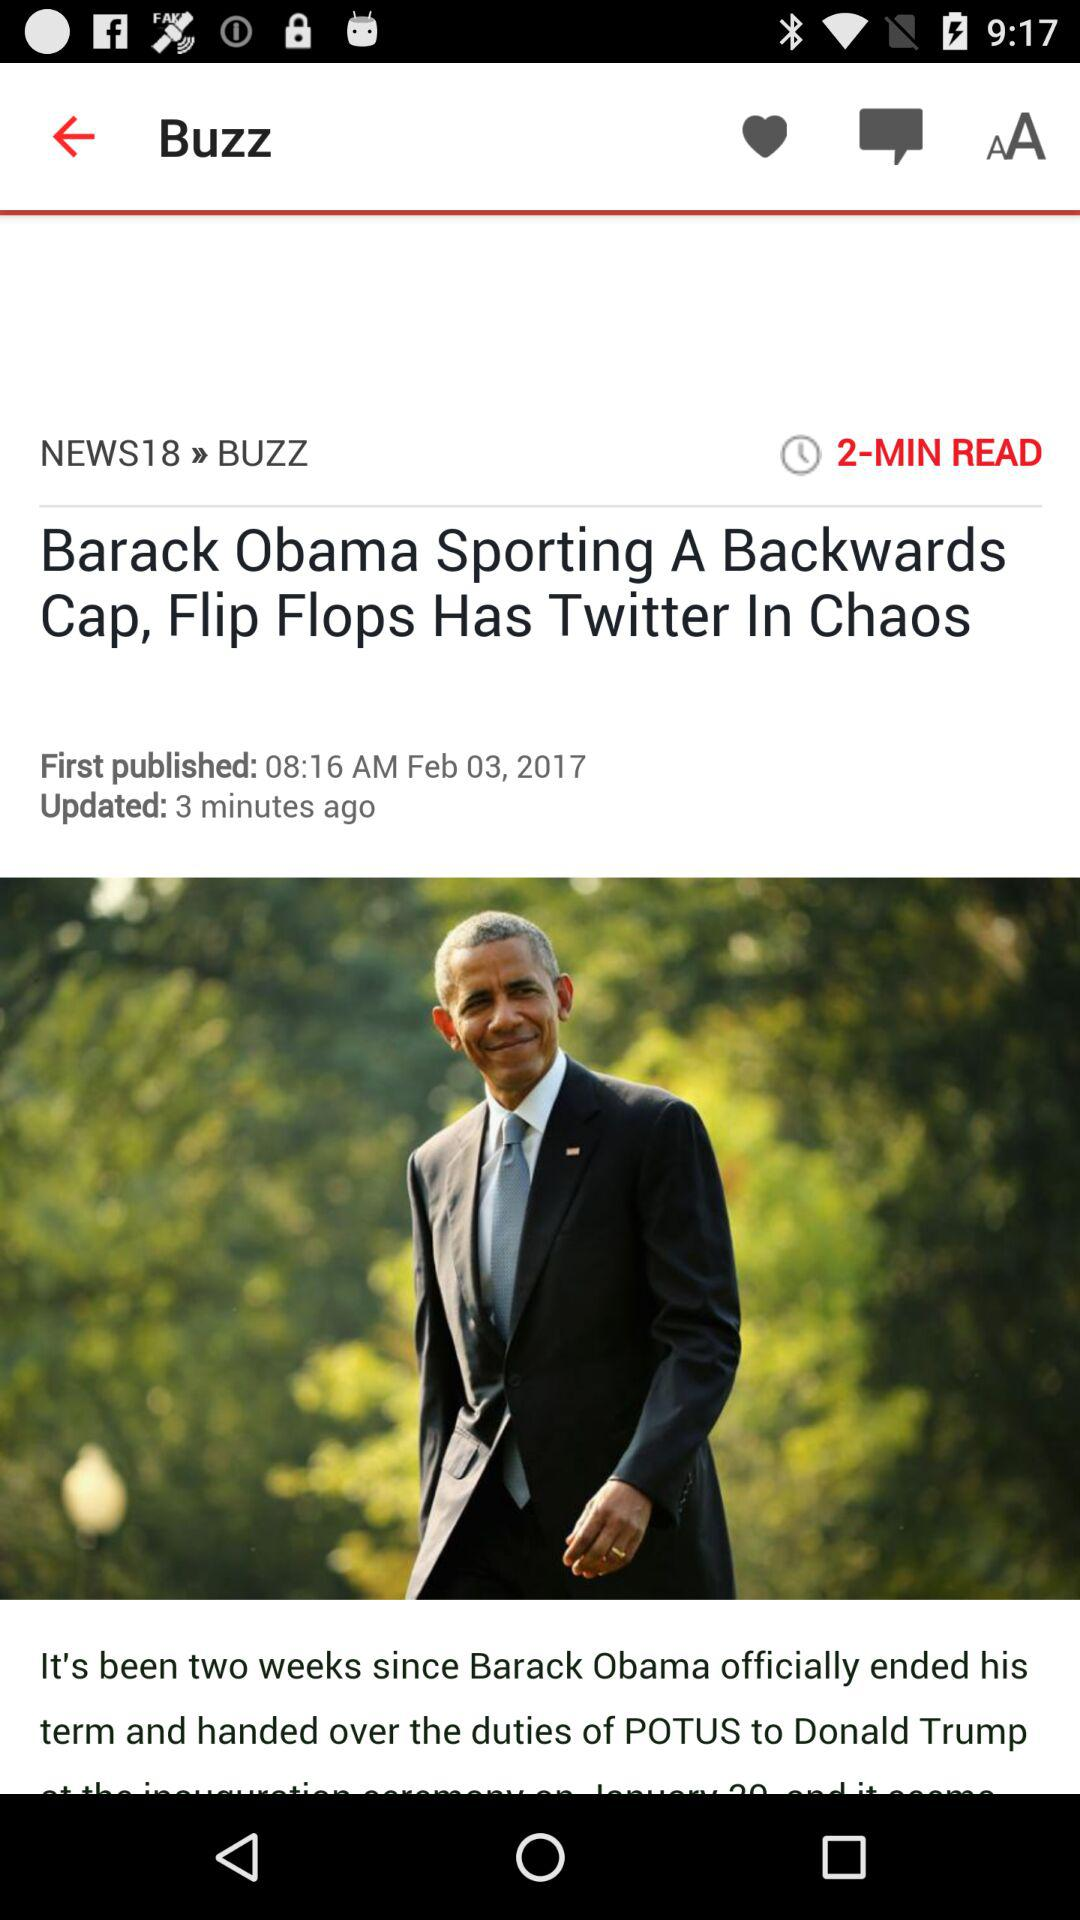When was the article first published? The article was first published on February 3, 2017 at 8:16 a.m. 